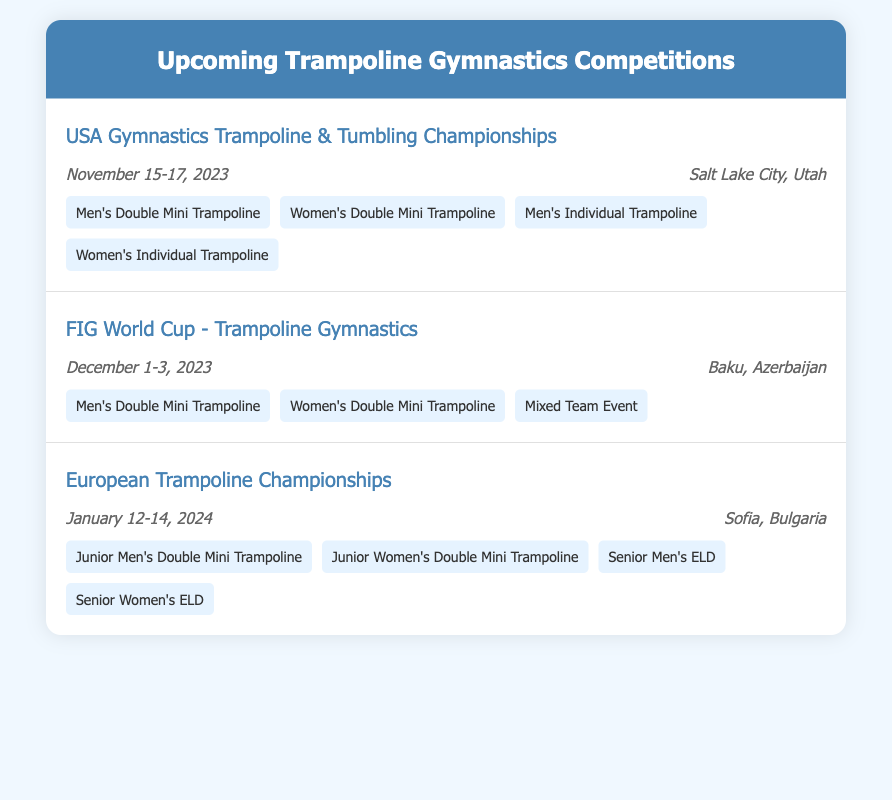what is the date of the USA Gymnastics Trampoline & Tumbling Championships? The date is mentioned in the document as November 15-17, 2023.
Answer: November 15-17, 2023 where is the FIG World Cup - Trampoline Gymnastics taking place? The location is specified in the document as Baku, Azerbaijan.
Answer: Baku, Azerbaijan which event features Junior Men's Double Mini Trampoline? This event is part of the European Trampoline Championships, as stated in the document.
Answer: European Trampoline Championships how many featured events are listed for the USA Gymnastics Trampoline & Tumbling Championships? The document lists four featured events for this competition.
Answer: Four what is the location of the European Trampoline Championships? The document specifies Sofia, Bulgaria as the location for this competition.
Answer: Sofia, Bulgaria is the Mixed Team Event featured in the USA Gymnastics Trampoline & Tumbling Championships? The document lists featured events for this competition, and Mixed Team Event is not included.
Answer: No which month will the FIG World Cup - Trampoline Gymnastics occur? According to the document, the event will take place in December.
Answer: December how many days will the European Trampoline Championships last? The event is scheduled for three days, as indicated by the dates provided.
Answer: Three days 